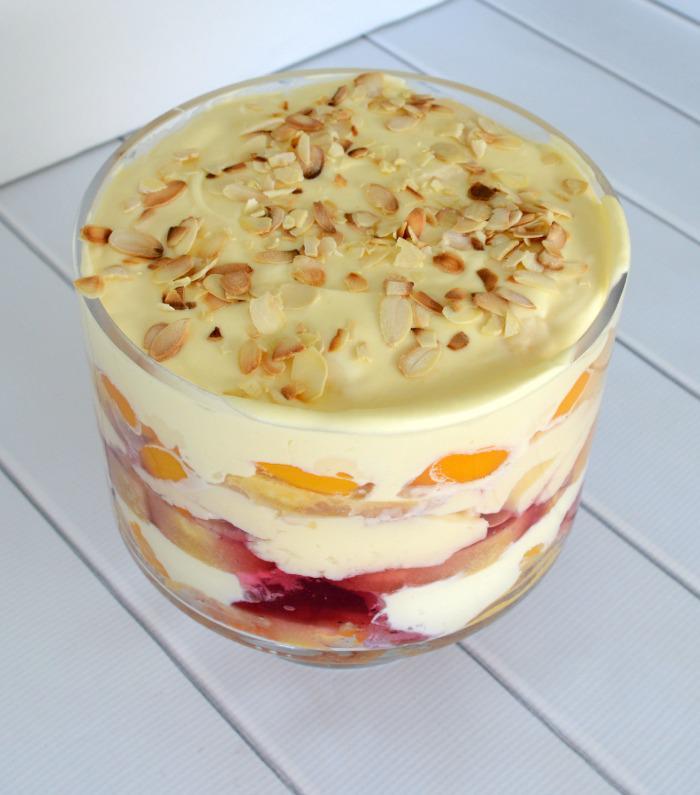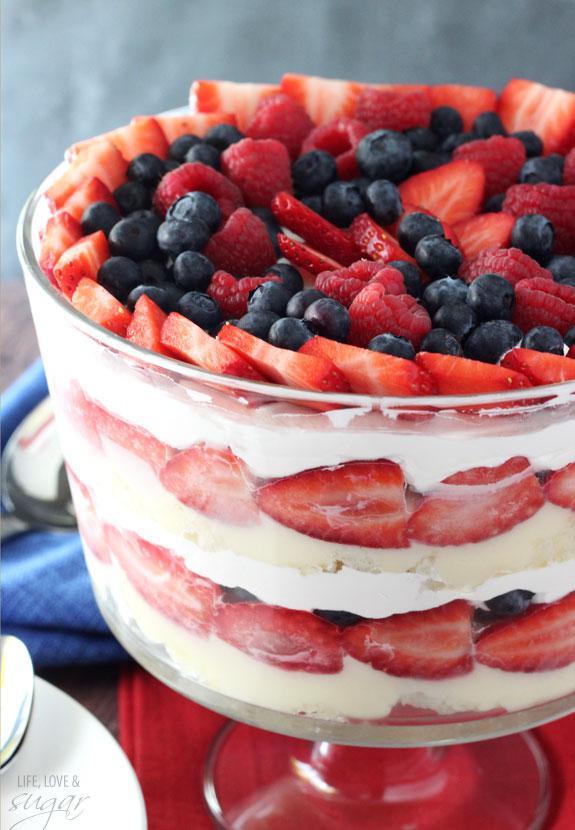The first image is the image on the left, the second image is the image on the right. For the images displayed, is the sentence "At least one image shows a dessert garnished only with strawberry slices." factually correct? Answer yes or no. No. The first image is the image on the left, the second image is the image on the right. Evaluate the accuracy of this statement regarding the images: "The serving dish in the image on the right has a pedastal.". Is it true? Answer yes or no. Yes. 